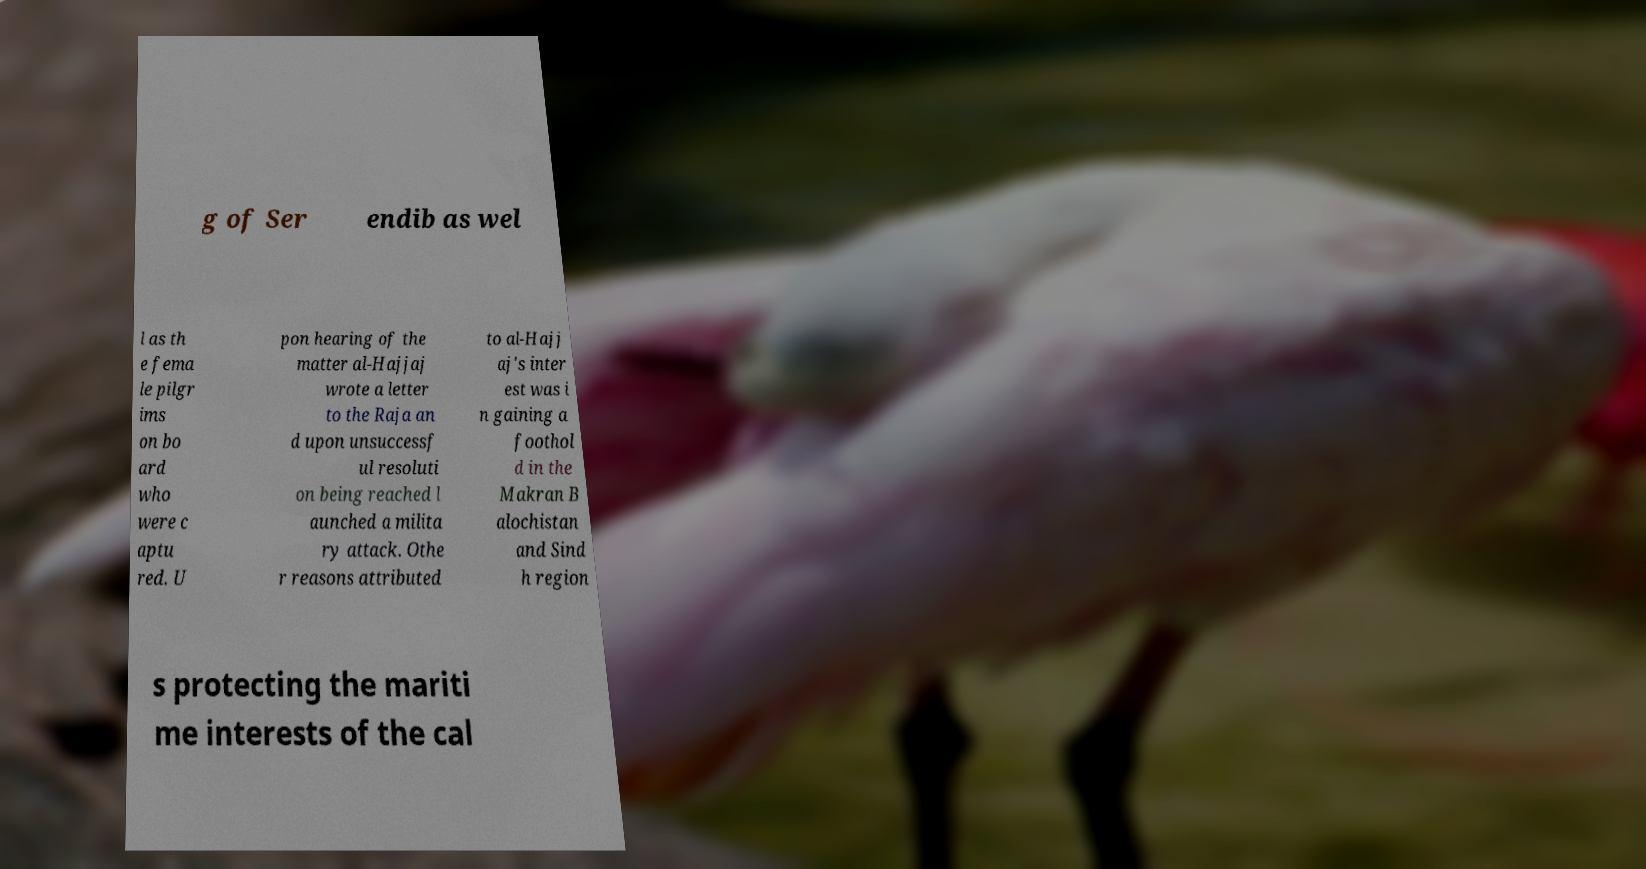Please read and relay the text visible in this image. What does it say? g of Ser endib as wel l as th e fema le pilgr ims on bo ard who were c aptu red. U pon hearing of the matter al-Hajjaj wrote a letter to the Raja an d upon unsuccessf ul resoluti on being reached l aunched a milita ry attack. Othe r reasons attributed to al-Hajj aj's inter est was i n gaining a foothol d in the Makran B alochistan and Sind h region s protecting the mariti me interests of the cal 